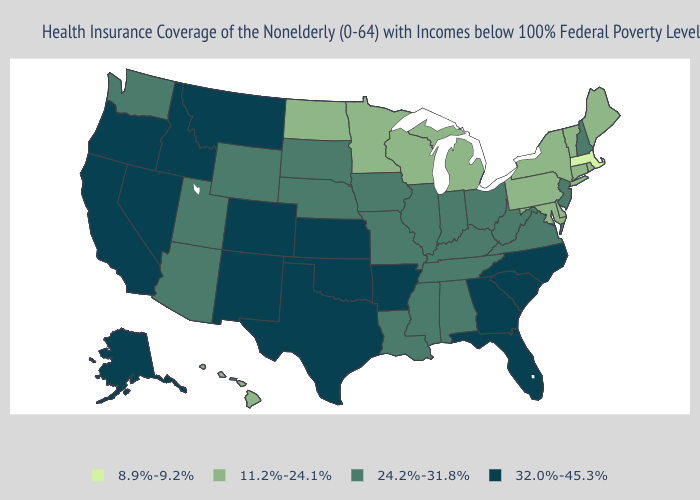Which states hav the highest value in the Northeast?
Keep it brief. New Hampshire, New Jersey. Name the states that have a value in the range 32.0%-45.3%?
Keep it brief. Alaska, Arkansas, California, Colorado, Florida, Georgia, Idaho, Kansas, Montana, Nevada, New Mexico, North Carolina, Oklahoma, Oregon, South Carolina, Texas. Among the states that border Kentucky , which have the highest value?
Concise answer only. Illinois, Indiana, Missouri, Ohio, Tennessee, Virginia, West Virginia. Among the states that border New Jersey , which have the highest value?
Give a very brief answer. Delaware, New York, Pennsylvania. Name the states that have a value in the range 8.9%-9.2%?
Keep it brief. Massachusetts. Which states have the lowest value in the USA?
Concise answer only. Massachusetts. Which states have the lowest value in the South?
Write a very short answer. Delaware, Maryland. Is the legend a continuous bar?
Give a very brief answer. No. Name the states that have a value in the range 11.2%-24.1%?
Concise answer only. Connecticut, Delaware, Hawaii, Maine, Maryland, Michigan, Minnesota, New York, North Dakota, Pennsylvania, Rhode Island, Vermont, Wisconsin. Does Massachusetts have the lowest value in the USA?
Write a very short answer. Yes. Does Vermont have the lowest value in the USA?
Concise answer only. No. Among the states that border Colorado , which have the lowest value?
Short answer required. Arizona, Nebraska, Utah, Wyoming. Among the states that border New Mexico , which have the highest value?
Write a very short answer. Colorado, Oklahoma, Texas. Name the states that have a value in the range 11.2%-24.1%?
Be succinct. Connecticut, Delaware, Hawaii, Maine, Maryland, Michigan, Minnesota, New York, North Dakota, Pennsylvania, Rhode Island, Vermont, Wisconsin. What is the lowest value in the South?
Answer briefly. 11.2%-24.1%. 